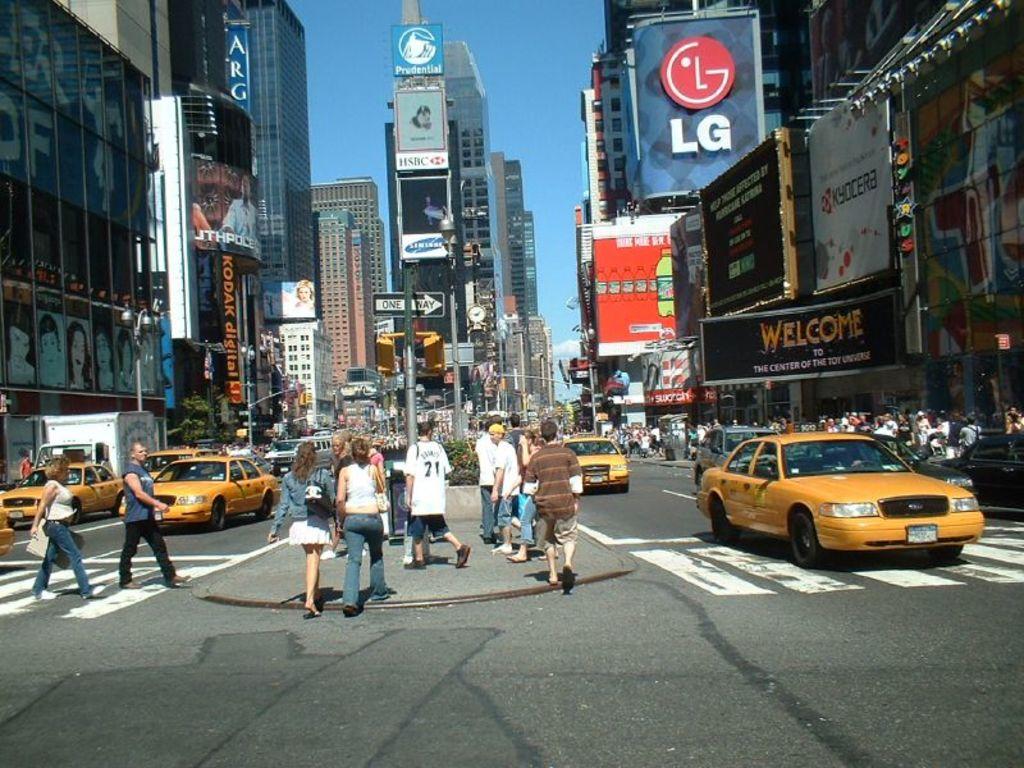What brand is under the pink logo?
Your answer should be very brief. Lg. What company is advertised in the upper right just right of center?
Provide a succinct answer. Lg. 